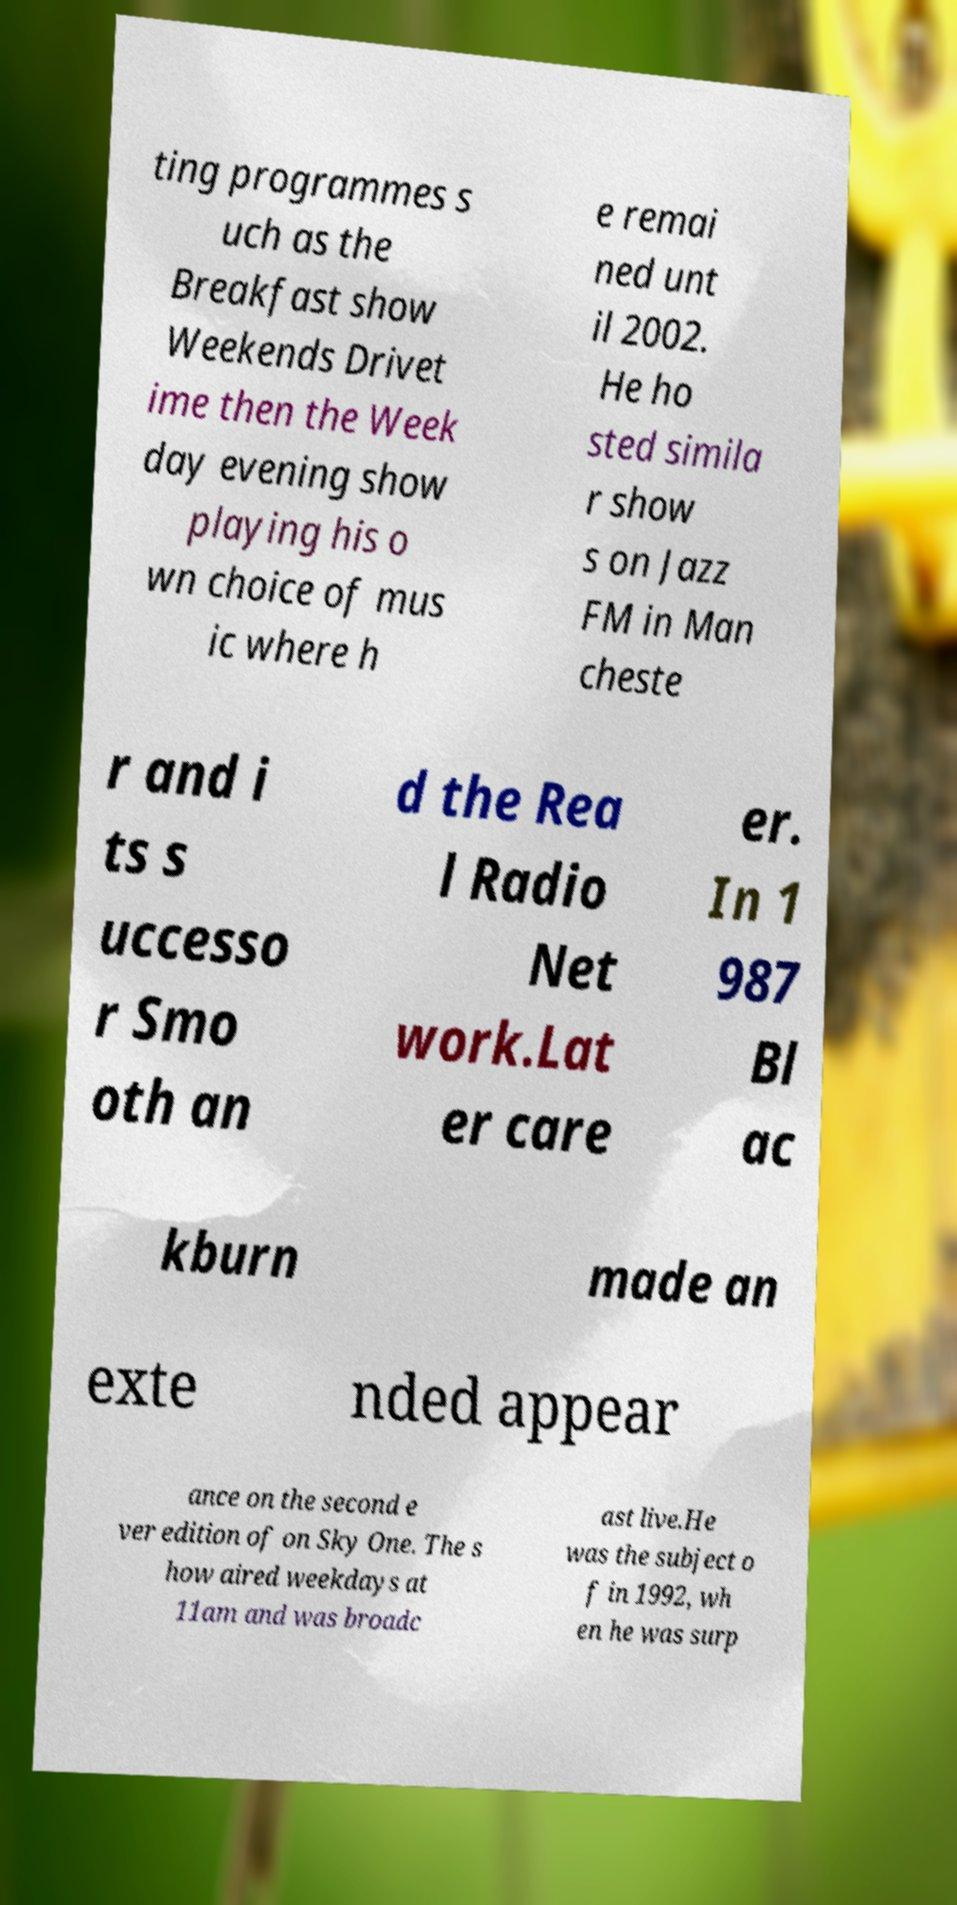Could you assist in decoding the text presented in this image and type it out clearly? ting programmes s uch as the Breakfast show Weekends Drivet ime then the Week day evening show playing his o wn choice of mus ic where h e remai ned unt il 2002. He ho sted simila r show s on Jazz FM in Man cheste r and i ts s uccesso r Smo oth an d the Rea l Radio Net work.Lat er care er. In 1 987 Bl ac kburn made an exte nded appear ance on the second e ver edition of on Sky One. The s how aired weekdays at 11am and was broadc ast live.He was the subject o f in 1992, wh en he was surp 